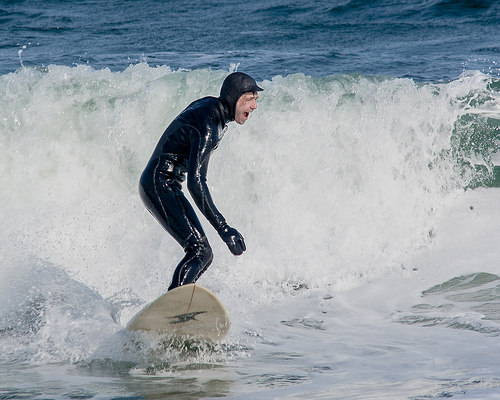<image>
Can you confirm if the man is next to the wave? No. The man is not positioned next to the wave. They are located in different areas of the scene. 